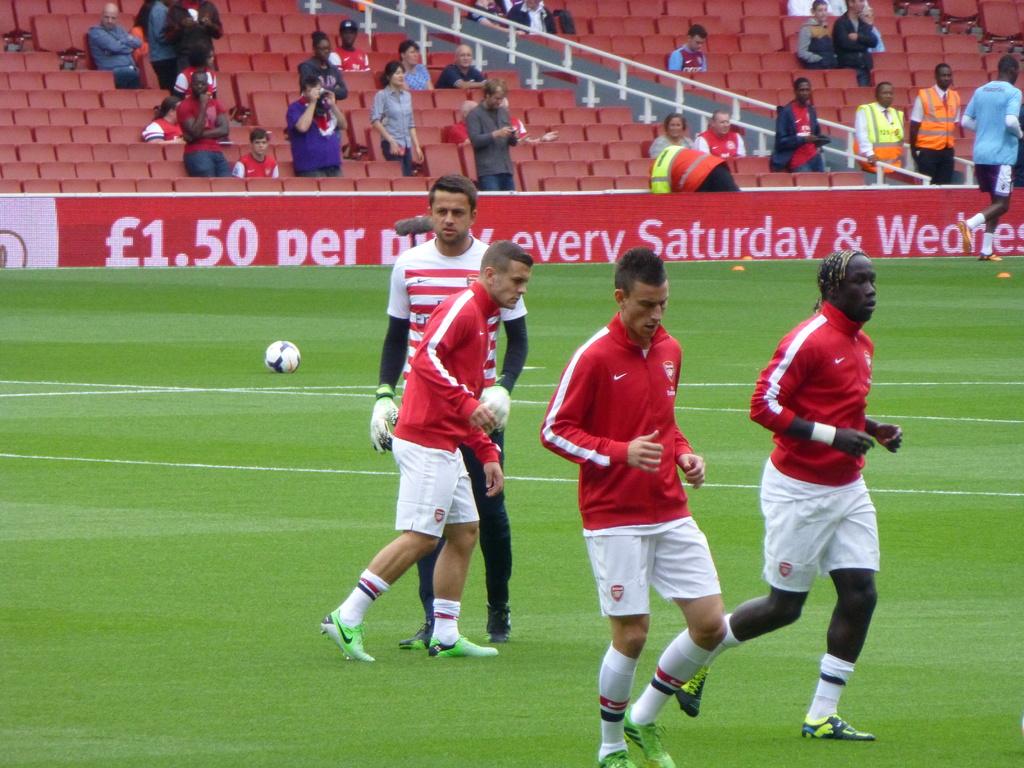How much is it every saturday and wednesday?
Keep it short and to the point. 1.50. 